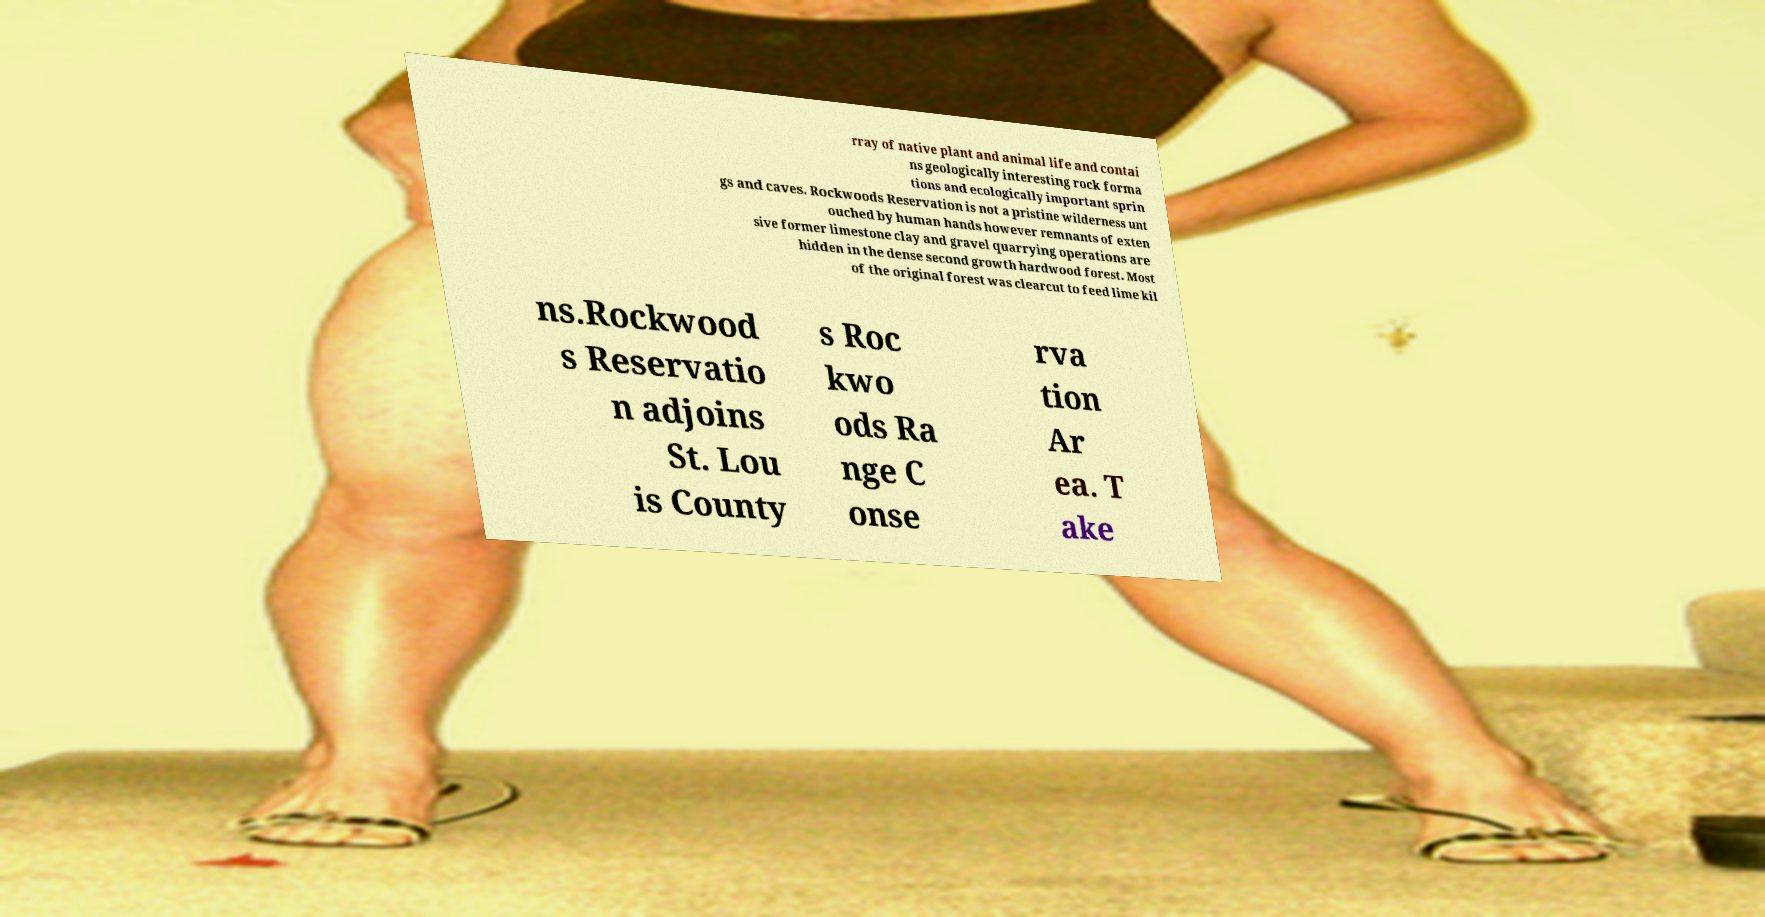I need the written content from this picture converted into text. Can you do that? rray of native plant and animal life and contai ns geologically interesting rock forma tions and ecologically important sprin gs and caves. Rockwoods Reservation is not a pristine wilderness unt ouched by human hands however remnants of exten sive former limestone clay and gravel quarrying operations are hidden in the dense second growth hardwood forest. Most of the original forest was clearcut to feed lime kil ns.Rockwood s Reservatio n adjoins St. Lou is County s Roc kwo ods Ra nge C onse rva tion Ar ea. T ake 